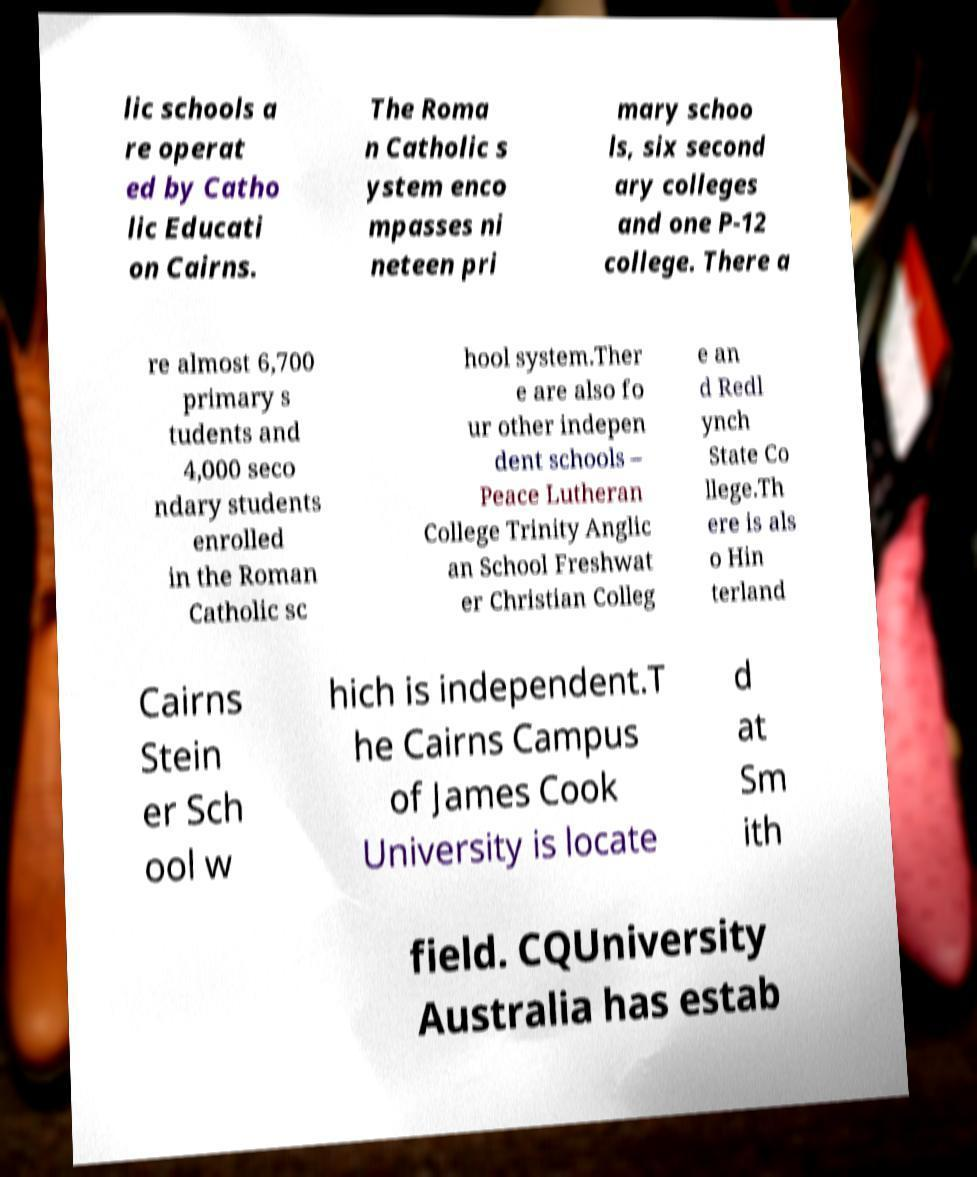Can you read and provide the text displayed in the image?This photo seems to have some interesting text. Can you extract and type it out for me? lic schools a re operat ed by Catho lic Educati on Cairns. The Roma n Catholic s ystem enco mpasses ni neteen pri mary schoo ls, six second ary colleges and one P-12 college. There a re almost 6,700 primary s tudents and 4,000 seco ndary students enrolled in the Roman Catholic sc hool system.Ther e are also fo ur other indepen dent schools – Peace Lutheran College Trinity Anglic an School Freshwat er Christian Colleg e an d Redl ynch State Co llege.Th ere is als o Hin terland Cairns Stein er Sch ool w hich is independent.T he Cairns Campus of James Cook University is locate d at Sm ith field. CQUniversity Australia has estab 